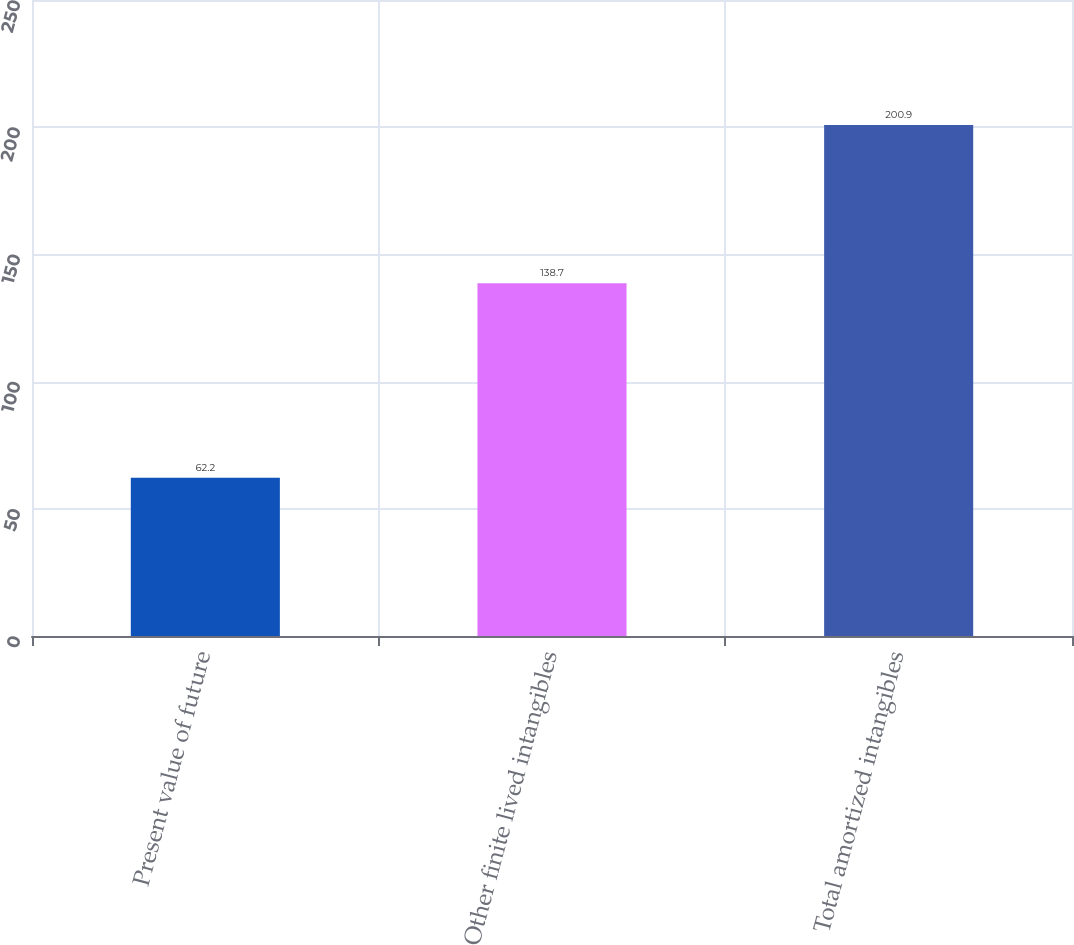<chart> <loc_0><loc_0><loc_500><loc_500><bar_chart><fcel>Present value of future<fcel>Other finite lived intangibles<fcel>Total amortized intangibles<nl><fcel>62.2<fcel>138.7<fcel>200.9<nl></chart> 